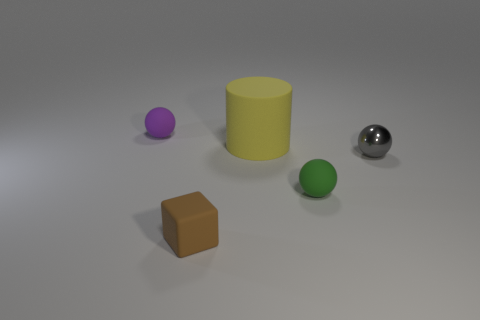Add 2 tiny green matte balls. How many objects exist? 7 Subtract all cylinders. How many objects are left? 4 Add 5 purple things. How many purple things are left? 6 Add 4 large things. How many large things exist? 5 Subtract 0 yellow blocks. How many objects are left? 5 Subtract all yellow cylinders. Subtract all small brown blocks. How many objects are left? 3 